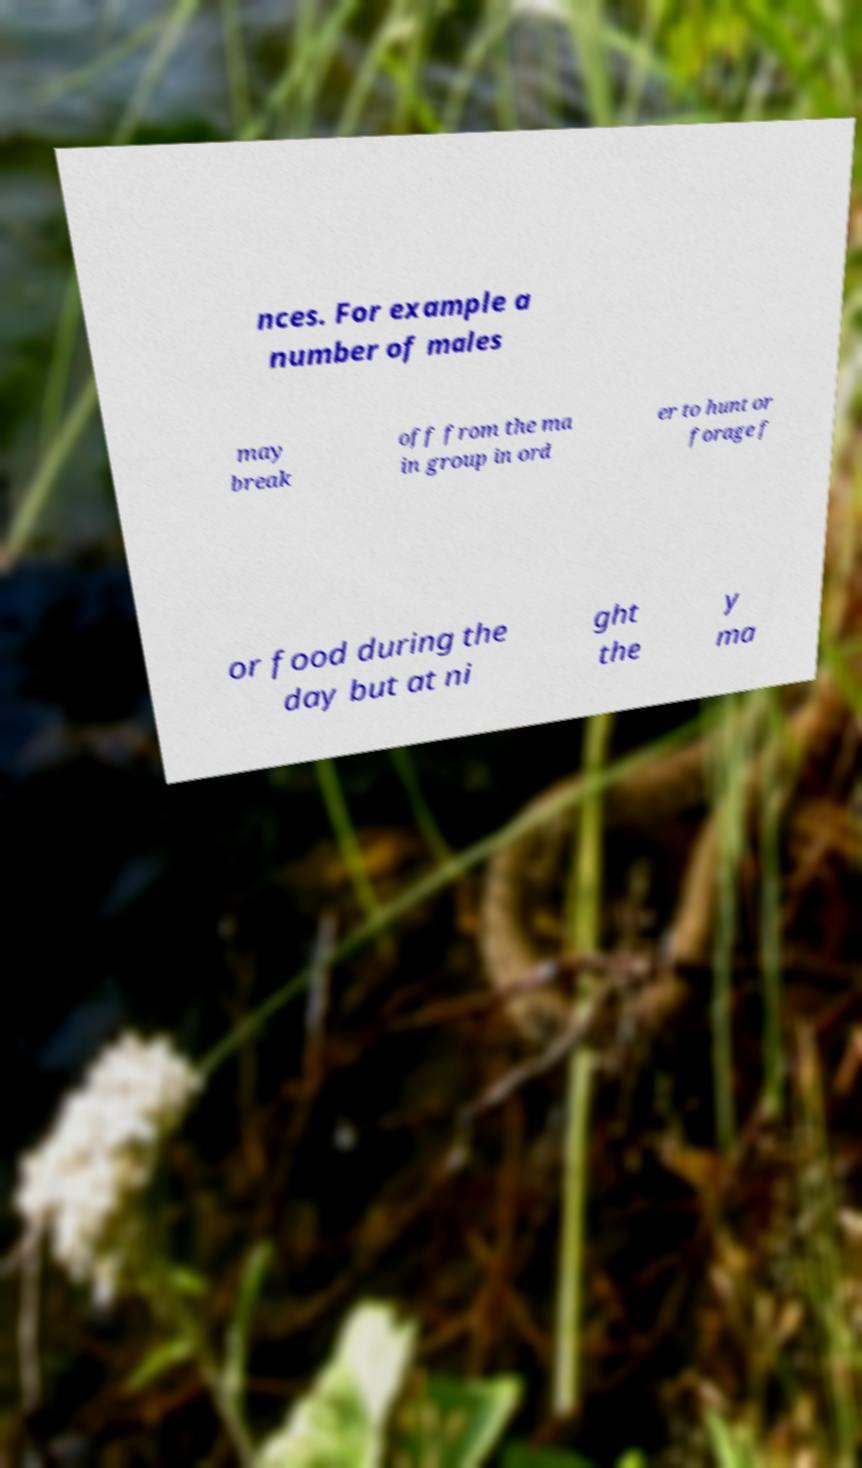I need the written content from this picture converted into text. Can you do that? nces. For example a number of males may break off from the ma in group in ord er to hunt or forage f or food during the day but at ni ght the y ma 